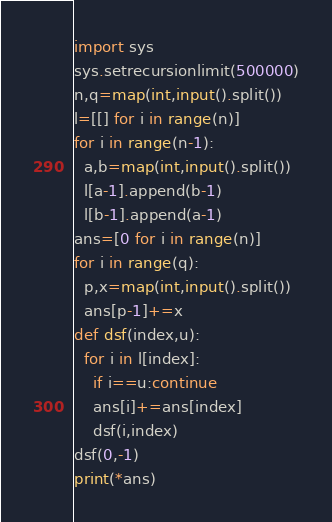<code> <loc_0><loc_0><loc_500><loc_500><_Python_>import sys
sys.setrecursionlimit(500000)
n,q=map(int,input().split())
l=[[] for i in range(n)]
for i in range(n-1):
  a,b=map(int,input().split())
  l[a-1].append(b-1)
  l[b-1].append(a-1)
ans=[0 for i in range(n)]
for i in range(q):
  p,x=map(int,input().split())
  ans[p-1]+=x
def dsf(index,u):
  for i in l[index]:
    if i==u:continue
    ans[i]+=ans[index]
    dsf(i,index)
dsf(0,-1)
print(*ans)</code> 